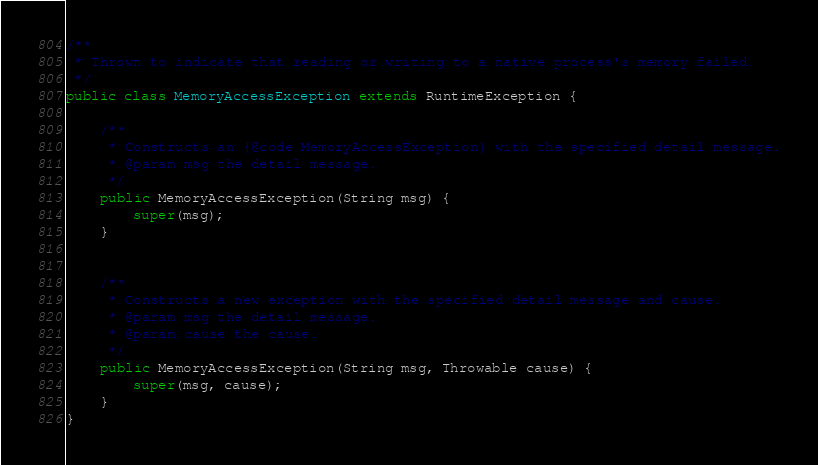<code> <loc_0><loc_0><loc_500><loc_500><_Java_>/**
 * Thrown to indicate that reading or writing to a native process's memory failed.
 */
public class MemoryAccessException extends RuntimeException {

    /**
     * Constructs an {@code MemoryAccessException} with the specified detail message.
     * @param msg the detail message.
     */
    public MemoryAccessException(String msg) {
        super(msg);
    }


    /**
     * Constructs a new exception with the specified detail message and cause.
     * @param msg the detail message.
     * @param cause the cause.
     */
    public MemoryAccessException(String msg, Throwable cause) {
        super(msg, cause);
    }
}
</code> 